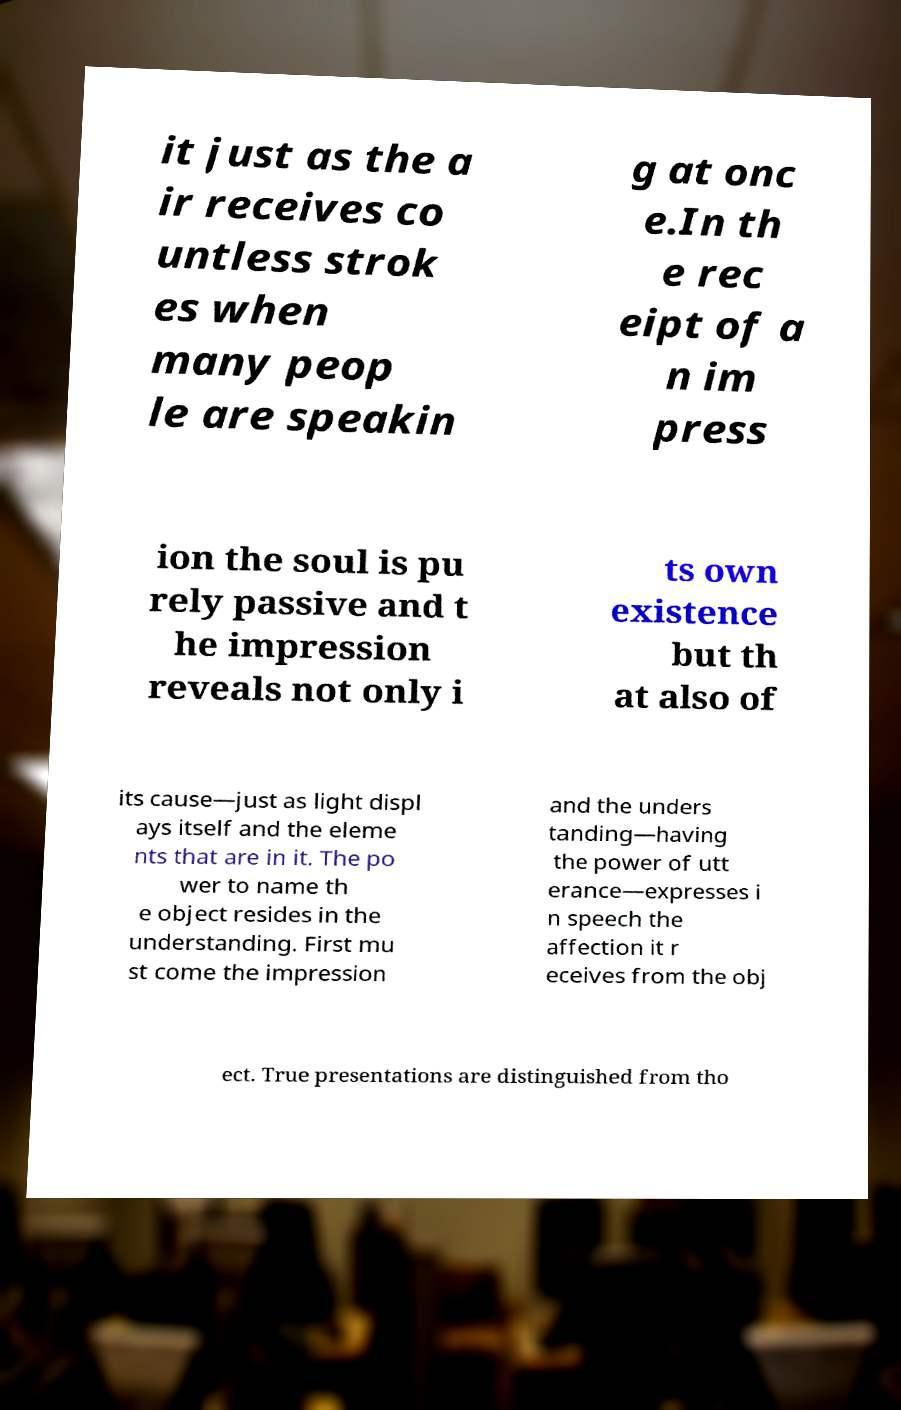For documentation purposes, I need the text within this image transcribed. Could you provide that? it just as the a ir receives co untless strok es when many peop le are speakin g at onc e.In th e rec eipt of a n im press ion the soul is pu rely passive and t he impression reveals not only i ts own existence but th at also of its cause—just as light displ ays itself and the eleme nts that are in it. The po wer to name th e object resides in the understanding. First mu st come the impression and the unders tanding—having the power of utt erance—expresses i n speech the affection it r eceives from the obj ect. True presentations are distinguished from tho 